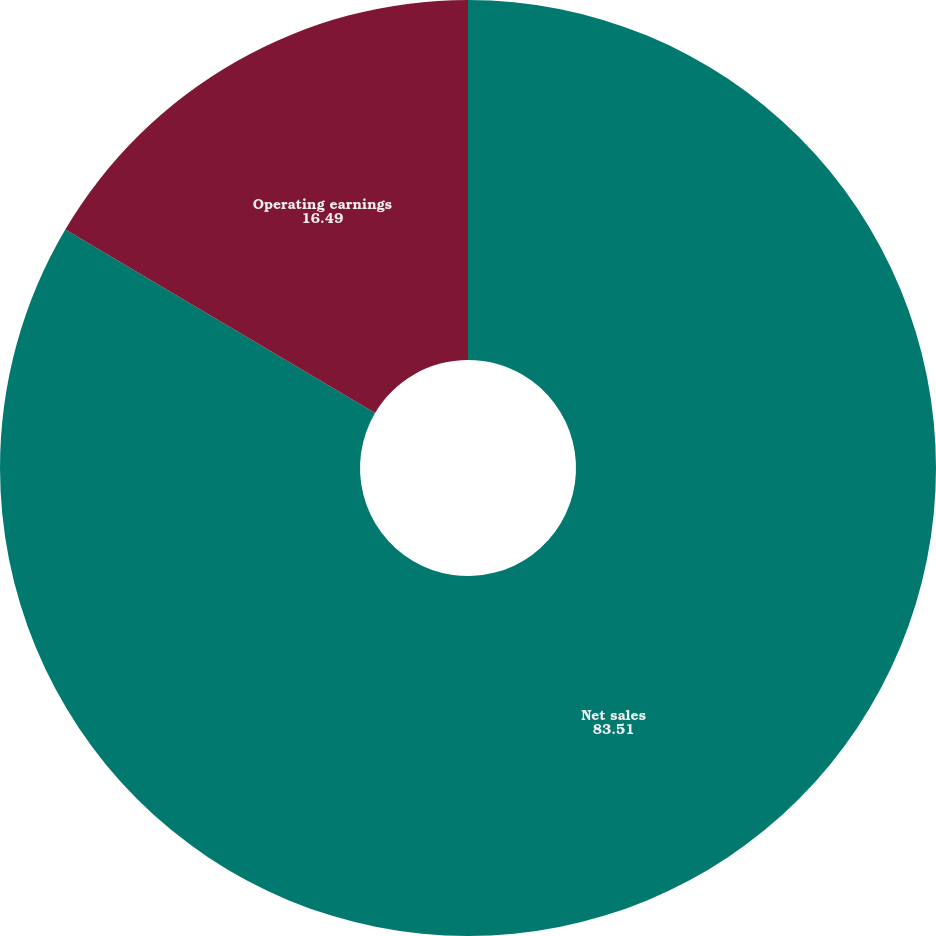<chart> <loc_0><loc_0><loc_500><loc_500><pie_chart><fcel>Net sales<fcel>Operating earnings<nl><fcel>83.51%<fcel>16.49%<nl></chart> 